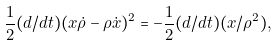<formula> <loc_0><loc_0><loc_500><loc_500>\frac { 1 } { 2 } ( d / d t ) ( x \dot { \rho } - \rho \dot { x } ) ^ { 2 } = - \frac { 1 } { 2 } ( d / d t ) ( x / \rho ^ { 2 } ) ,</formula> 